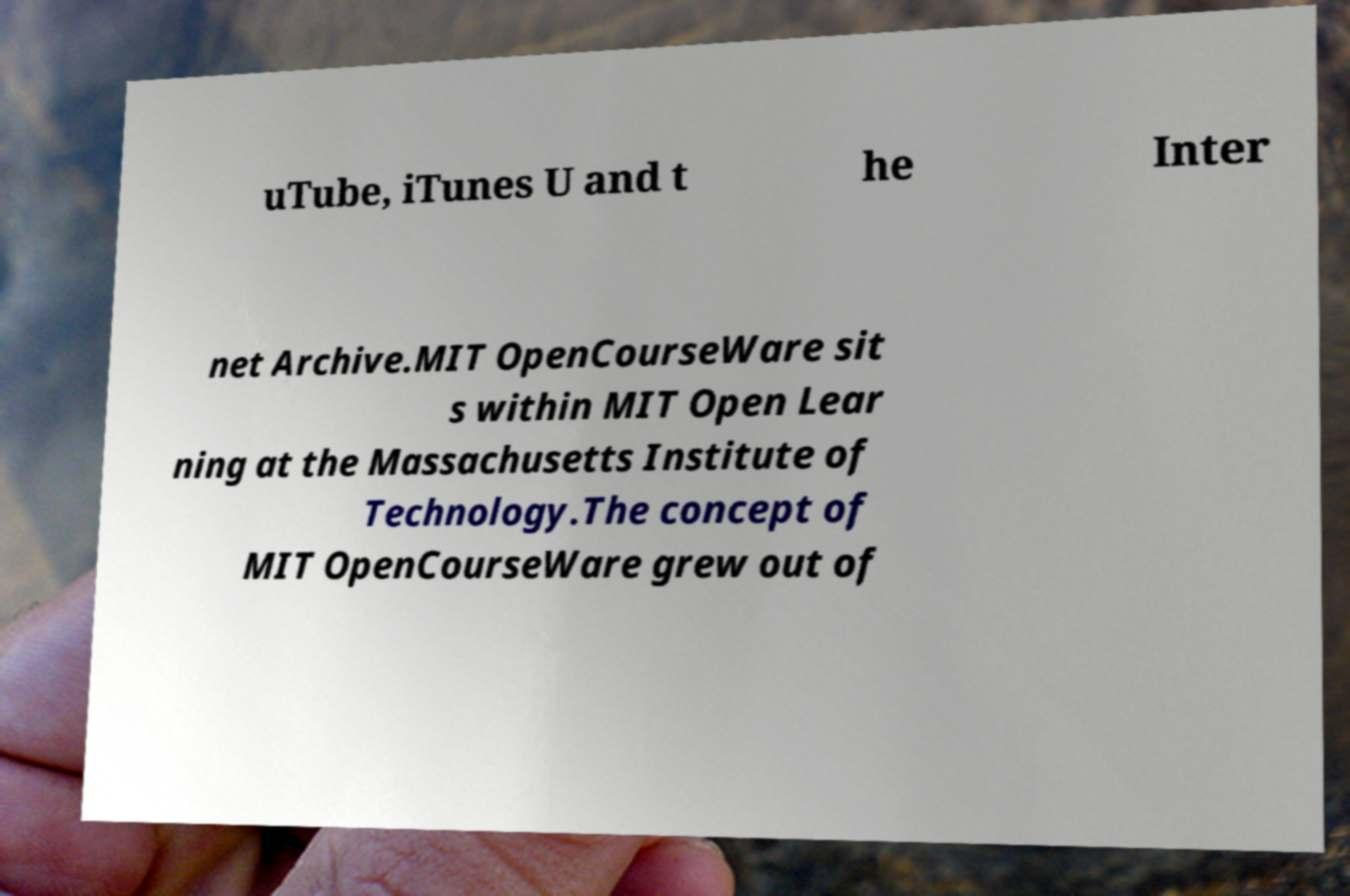For documentation purposes, I need the text within this image transcribed. Could you provide that? uTube, iTunes U and t he Inter net Archive.MIT OpenCourseWare sit s within MIT Open Lear ning at the Massachusetts Institute of Technology.The concept of MIT OpenCourseWare grew out of 